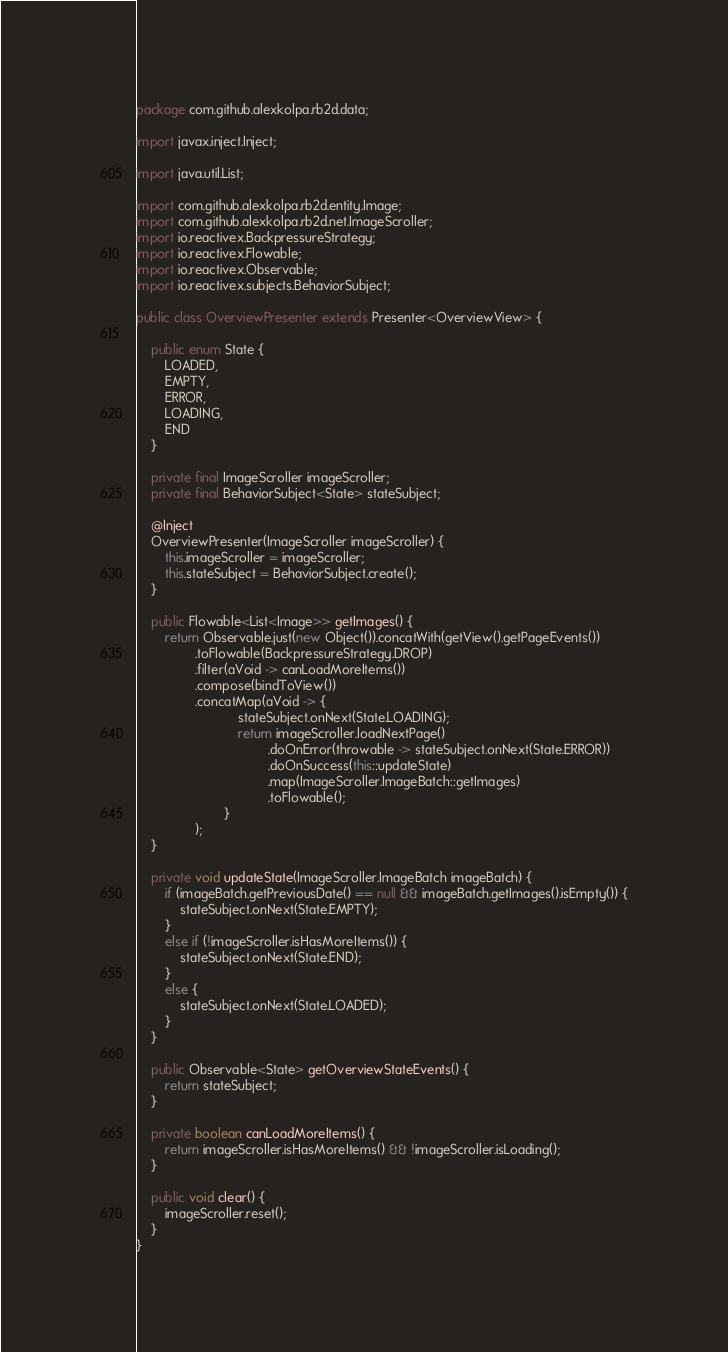<code> <loc_0><loc_0><loc_500><loc_500><_Java_>package com.github.alexkolpa.rb2d.data;

import javax.inject.Inject;

import java.util.List;

import com.github.alexkolpa.rb2d.entity.Image;
import com.github.alexkolpa.rb2d.net.ImageScroller;
import io.reactivex.BackpressureStrategy;
import io.reactivex.Flowable;
import io.reactivex.Observable;
import io.reactivex.subjects.BehaviorSubject;

public class OverviewPresenter extends Presenter<OverviewView> {

	public enum State {
		LOADED,
		EMPTY,
		ERROR,
		LOADING,
		END
	}

	private final ImageScroller imageScroller;
	private final BehaviorSubject<State> stateSubject;

	@Inject
	OverviewPresenter(ImageScroller imageScroller) {
		this.imageScroller = imageScroller;
		this.stateSubject = BehaviorSubject.create();
	}

	public Flowable<List<Image>> getImages() {
		return Observable.just(new Object()).concatWith(getView().getPageEvents())
				.toFlowable(BackpressureStrategy.DROP)
				.filter(aVoid -> canLoadMoreItems())
				.compose(bindToView())
				.concatMap(aVoid -> {
							stateSubject.onNext(State.LOADING);
							return imageScroller.loadNextPage()
									.doOnError(throwable -> stateSubject.onNext(State.ERROR))
									.doOnSuccess(this::updateState)
									.map(ImageScroller.ImageBatch::getImages)
									.toFlowable();
						}
				);
	}

	private void updateState(ImageScroller.ImageBatch imageBatch) {
		if (imageBatch.getPreviousDate() == null && imageBatch.getImages().isEmpty()) {
			stateSubject.onNext(State.EMPTY);
		}
		else if (!imageScroller.isHasMoreItems()) {
			stateSubject.onNext(State.END);
		}
		else {
			stateSubject.onNext(State.LOADED);
		}
	}

	public Observable<State> getOverviewStateEvents() {
		return stateSubject;
	}

	private boolean canLoadMoreItems() {
		return imageScroller.isHasMoreItems() && !imageScroller.isLoading();
	}

	public void clear() {
		imageScroller.reset();
	}
}

</code> 